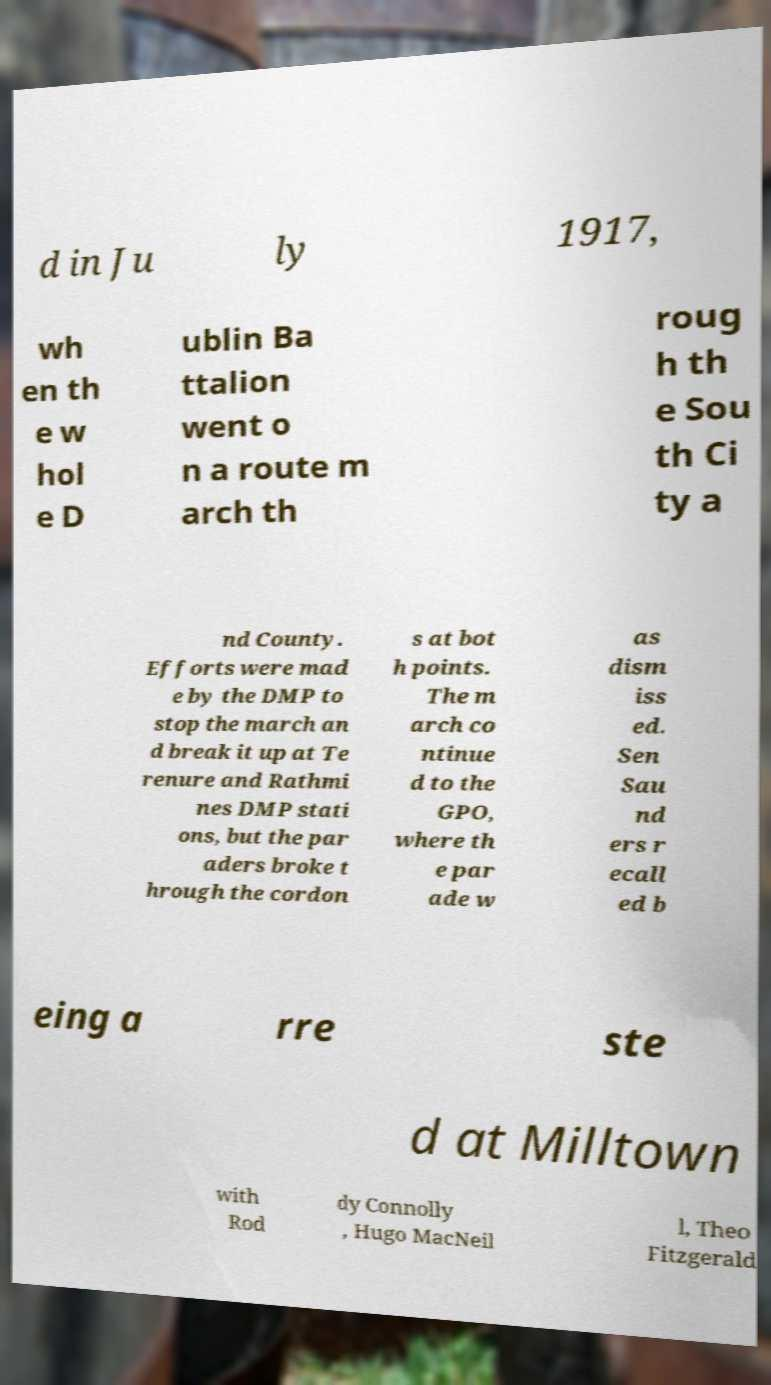Could you extract and type out the text from this image? d in Ju ly 1917, wh en th e w hol e D ublin Ba ttalion went o n a route m arch th roug h th e Sou th Ci ty a nd County. Efforts were mad e by the DMP to stop the march an d break it up at Te renure and Rathmi nes DMP stati ons, but the par aders broke t hrough the cordon s at bot h points. The m arch co ntinue d to the GPO, where th e par ade w as dism iss ed. Sen Sau nd ers r ecall ed b eing a rre ste d at Milltown with Rod dy Connolly , Hugo MacNeil l, Theo Fitzgerald 